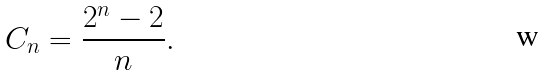Convert formula to latex. <formula><loc_0><loc_0><loc_500><loc_500>C _ { n } = \frac { 2 ^ { n } - 2 } { n } .</formula> 